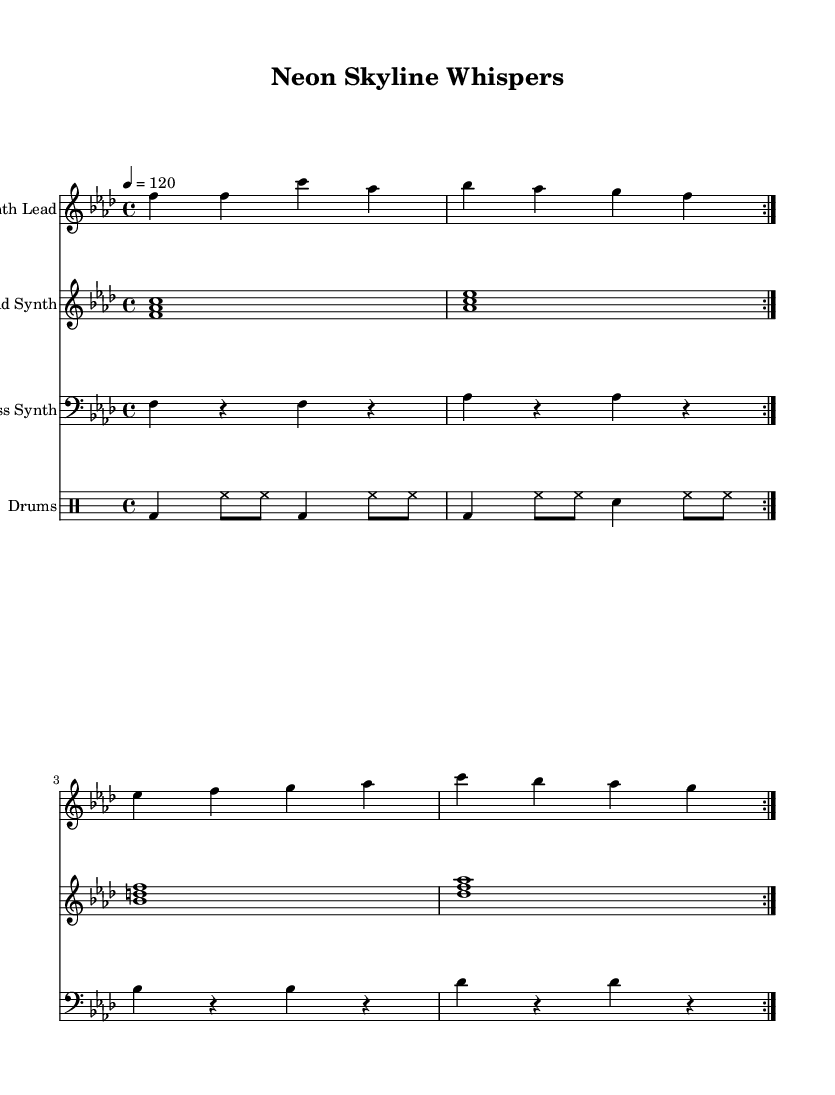What is the key signature of this music? The key signature is F minor, which has four flats (B♭, E♭, A♭, and D♭). This can be identified by looking at the key signature indicated at the beginning of the staff.
Answer: F minor What is the time signature of this music? The time signature is 4/4, which means there are four beats in each measure and the quarter note gets one beat. This can be found at the beginning of the score, right after the key signature.
Answer: 4/4 What is the tempo of this piece? The tempo is marked at 120 beats per minute, indicated by the tempo marking at the beginning of the score. This specifies the speed at which the music is to be played.
Answer: 120 How many measures are repeated in the synth lead section? There are two measures that are repeated in the synth lead section, as indicated by the repeat signs (volta) within that part. This means the section plays through twice before proceeding.
Answer: 2 What type of instrument is the bass part notated for? The bass part is notated for the bass synth, indicated by the instrument name above that particular staff in the score. This signifies that it is meant to be played by a synthesizer tuned to a lower pitch register.
Answer: Bass Synth How many types of instruments are present in this composition? There are four types of instruments present: Synth Lead, Pad Synth, Bass Synth, and Drums. Each of these are provided with their own staff in the rendered score, making it clear how many different instrument parts are included.
Answer: 4 What are the main characteristics of house music reflected in this sheet music? The main characteristics of house music reflected in this sheet music include a steady 4/4 beat, synth-based melodies, and repetition of musical phrases for a hypnotic effect. These elements are essential to the genre, which often features electronic production and rhythmic consistency.
Answer: Steady 4/4 beat, synth melodies, repetition 